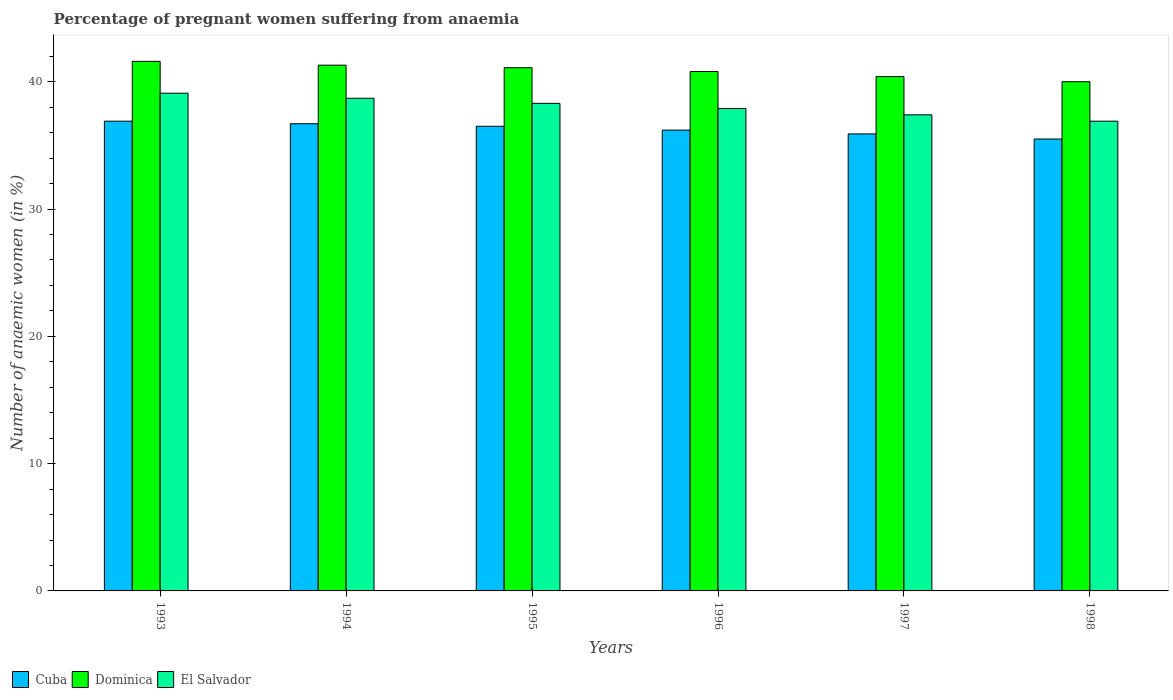Are the number of bars per tick equal to the number of legend labels?
Your answer should be very brief. Yes. How many bars are there on the 3rd tick from the left?
Provide a short and direct response. 3. How many bars are there on the 4th tick from the right?
Keep it short and to the point. 3. What is the label of the 1st group of bars from the left?
Give a very brief answer. 1993. In how many cases, is the number of bars for a given year not equal to the number of legend labels?
Make the answer very short. 0. What is the number of anaemic women in Dominica in 1994?
Give a very brief answer. 41.3. Across all years, what is the maximum number of anaemic women in Dominica?
Your answer should be very brief. 41.6. Across all years, what is the minimum number of anaemic women in Cuba?
Provide a succinct answer. 35.5. In which year was the number of anaemic women in El Salvador minimum?
Your answer should be compact. 1998. What is the total number of anaemic women in Dominica in the graph?
Offer a very short reply. 245.2. What is the difference between the number of anaemic women in Cuba in 1998 and the number of anaemic women in Dominica in 1994?
Your answer should be very brief. -5.8. What is the average number of anaemic women in Dominica per year?
Ensure brevity in your answer.  40.87. In the year 1998, what is the difference between the number of anaemic women in Dominica and number of anaemic women in El Salvador?
Your answer should be very brief. 3.1. What is the ratio of the number of anaemic women in El Salvador in 1993 to that in 1996?
Your answer should be compact. 1.03. What is the difference between the highest and the second highest number of anaemic women in Cuba?
Your answer should be compact. 0.2. What is the difference between the highest and the lowest number of anaemic women in El Salvador?
Provide a short and direct response. 2.2. What does the 2nd bar from the left in 1997 represents?
Offer a very short reply. Dominica. What does the 2nd bar from the right in 1995 represents?
Ensure brevity in your answer.  Dominica. Are the values on the major ticks of Y-axis written in scientific E-notation?
Offer a terse response. No. Does the graph contain any zero values?
Keep it short and to the point. No. Does the graph contain grids?
Keep it short and to the point. No. Where does the legend appear in the graph?
Offer a terse response. Bottom left. What is the title of the graph?
Make the answer very short. Percentage of pregnant women suffering from anaemia. What is the label or title of the Y-axis?
Give a very brief answer. Number of anaemic women (in %). What is the Number of anaemic women (in %) in Cuba in 1993?
Make the answer very short. 36.9. What is the Number of anaemic women (in %) of Dominica in 1993?
Offer a very short reply. 41.6. What is the Number of anaemic women (in %) in El Salvador in 1993?
Your response must be concise. 39.1. What is the Number of anaemic women (in %) of Cuba in 1994?
Your answer should be compact. 36.7. What is the Number of anaemic women (in %) of Dominica in 1994?
Your answer should be compact. 41.3. What is the Number of anaemic women (in %) in El Salvador in 1994?
Your answer should be very brief. 38.7. What is the Number of anaemic women (in %) in Cuba in 1995?
Your answer should be very brief. 36.5. What is the Number of anaemic women (in %) in Dominica in 1995?
Provide a succinct answer. 41.1. What is the Number of anaemic women (in %) of El Salvador in 1995?
Your answer should be very brief. 38.3. What is the Number of anaemic women (in %) in Cuba in 1996?
Your answer should be very brief. 36.2. What is the Number of anaemic women (in %) in Dominica in 1996?
Ensure brevity in your answer.  40.8. What is the Number of anaemic women (in %) of El Salvador in 1996?
Your answer should be very brief. 37.9. What is the Number of anaemic women (in %) of Cuba in 1997?
Ensure brevity in your answer.  35.9. What is the Number of anaemic women (in %) of Dominica in 1997?
Provide a succinct answer. 40.4. What is the Number of anaemic women (in %) of El Salvador in 1997?
Ensure brevity in your answer.  37.4. What is the Number of anaemic women (in %) of Cuba in 1998?
Your response must be concise. 35.5. What is the Number of anaemic women (in %) in Dominica in 1998?
Your answer should be compact. 40. What is the Number of anaemic women (in %) of El Salvador in 1998?
Give a very brief answer. 36.9. Across all years, what is the maximum Number of anaemic women (in %) in Cuba?
Make the answer very short. 36.9. Across all years, what is the maximum Number of anaemic women (in %) of Dominica?
Your answer should be very brief. 41.6. Across all years, what is the maximum Number of anaemic women (in %) in El Salvador?
Your answer should be compact. 39.1. Across all years, what is the minimum Number of anaemic women (in %) in Cuba?
Your answer should be compact. 35.5. Across all years, what is the minimum Number of anaemic women (in %) in El Salvador?
Your answer should be very brief. 36.9. What is the total Number of anaemic women (in %) in Cuba in the graph?
Give a very brief answer. 217.7. What is the total Number of anaemic women (in %) of Dominica in the graph?
Provide a succinct answer. 245.2. What is the total Number of anaemic women (in %) of El Salvador in the graph?
Ensure brevity in your answer.  228.3. What is the difference between the Number of anaemic women (in %) in Dominica in 1993 and that in 1994?
Provide a short and direct response. 0.3. What is the difference between the Number of anaemic women (in %) of Cuba in 1993 and that in 1996?
Your response must be concise. 0.7. What is the difference between the Number of anaemic women (in %) of Dominica in 1993 and that in 1996?
Offer a terse response. 0.8. What is the difference between the Number of anaemic women (in %) of El Salvador in 1993 and that in 1996?
Your answer should be very brief. 1.2. What is the difference between the Number of anaemic women (in %) of Cuba in 1993 and that in 1997?
Ensure brevity in your answer.  1. What is the difference between the Number of anaemic women (in %) in Dominica in 1993 and that in 1997?
Provide a succinct answer. 1.2. What is the difference between the Number of anaemic women (in %) of El Salvador in 1993 and that in 1997?
Provide a short and direct response. 1.7. What is the difference between the Number of anaemic women (in %) of Cuba in 1993 and that in 1998?
Offer a very short reply. 1.4. What is the difference between the Number of anaemic women (in %) in Cuba in 1994 and that in 1995?
Provide a short and direct response. 0.2. What is the difference between the Number of anaemic women (in %) of Dominica in 1994 and that in 1995?
Offer a terse response. 0.2. What is the difference between the Number of anaemic women (in %) in El Salvador in 1994 and that in 1996?
Your answer should be very brief. 0.8. What is the difference between the Number of anaemic women (in %) in Cuba in 1994 and that in 1997?
Your response must be concise. 0.8. What is the difference between the Number of anaemic women (in %) in El Salvador in 1994 and that in 1997?
Your answer should be compact. 1.3. What is the difference between the Number of anaemic women (in %) of Cuba in 1994 and that in 1998?
Your answer should be compact. 1.2. What is the difference between the Number of anaemic women (in %) in Dominica in 1994 and that in 1998?
Make the answer very short. 1.3. What is the difference between the Number of anaemic women (in %) of Cuba in 1995 and that in 1996?
Give a very brief answer. 0.3. What is the difference between the Number of anaemic women (in %) in Dominica in 1995 and that in 1996?
Your answer should be very brief. 0.3. What is the difference between the Number of anaemic women (in %) of El Salvador in 1995 and that in 1996?
Offer a very short reply. 0.4. What is the difference between the Number of anaemic women (in %) in Cuba in 1995 and that in 1998?
Offer a very short reply. 1. What is the difference between the Number of anaemic women (in %) of Dominica in 1995 and that in 1998?
Ensure brevity in your answer.  1.1. What is the difference between the Number of anaemic women (in %) of Dominica in 1996 and that in 1997?
Your response must be concise. 0.4. What is the difference between the Number of anaemic women (in %) in El Salvador in 1996 and that in 1997?
Keep it short and to the point. 0.5. What is the difference between the Number of anaemic women (in %) of Cuba in 1996 and that in 1998?
Ensure brevity in your answer.  0.7. What is the difference between the Number of anaemic women (in %) of El Salvador in 1996 and that in 1998?
Offer a very short reply. 1. What is the difference between the Number of anaemic women (in %) in Cuba in 1997 and that in 1998?
Ensure brevity in your answer.  0.4. What is the difference between the Number of anaemic women (in %) of Dominica in 1997 and that in 1998?
Provide a short and direct response. 0.4. What is the difference between the Number of anaemic women (in %) of El Salvador in 1997 and that in 1998?
Your response must be concise. 0.5. What is the difference between the Number of anaemic women (in %) in Dominica in 1993 and the Number of anaemic women (in %) in El Salvador in 1994?
Provide a succinct answer. 2.9. What is the difference between the Number of anaemic women (in %) in Dominica in 1993 and the Number of anaemic women (in %) in El Salvador in 1995?
Your answer should be compact. 3.3. What is the difference between the Number of anaemic women (in %) in Dominica in 1993 and the Number of anaemic women (in %) in El Salvador in 1996?
Make the answer very short. 3.7. What is the difference between the Number of anaemic women (in %) of Cuba in 1993 and the Number of anaemic women (in %) of El Salvador in 1997?
Make the answer very short. -0.5. What is the difference between the Number of anaemic women (in %) in Dominica in 1993 and the Number of anaemic women (in %) in El Salvador in 1997?
Keep it short and to the point. 4.2. What is the difference between the Number of anaemic women (in %) of Cuba in 1994 and the Number of anaemic women (in %) of Dominica in 1995?
Make the answer very short. -4.4. What is the difference between the Number of anaemic women (in %) of Cuba in 1994 and the Number of anaemic women (in %) of El Salvador in 1996?
Your response must be concise. -1.2. What is the difference between the Number of anaemic women (in %) of Dominica in 1994 and the Number of anaemic women (in %) of El Salvador in 1996?
Offer a terse response. 3.4. What is the difference between the Number of anaemic women (in %) of Cuba in 1994 and the Number of anaemic women (in %) of El Salvador in 1997?
Offer a terse response. -0.7. What is the difference between the Number of anaemic women (in %) of Dominica in 1994 and the Number of anaemic women (in %) of El Salvador in 1997?
Your answer should be compact. 3.9. What is the difference between the Number of anaemic women (in %) in Cuba in 1994 and the Number of anaemic women (in %) in Dominica in 1998?
Make the answer very short. -3.3. What is the difference between the Number of anaemic women (in %) of Cuba in 1995 and the Number of anaemic women (in %) of Dominica in 1997?
Keep it short and to the point. -3.9. What is the difference between the Number of anaemic women (in %) in Cuba in 1995 and the Number of anaemic women (in %) in El Salvador in 1997?
Provide a succinct answer. -0.9. What is the difference between the Number of anaemic women (in %) of Dominica in 1995 and the Number of anaemic women (in %) of El Salvador in 1997?
Provide a short and direct response. 3.7. What is the difference between the Number of anaemic women (in %) in Dominica in 1995 and the Number of anaemic women (in %) in El Salvador in 1998?
Give a very brief answer. 4.2. What is the difference between the Number of anaemic women (in %) in Cuba in 1996 and the Number of anaemic women (in %) in El Salvador in 1997?
Give a very brief answer. -1.2. What is the difference between the Number of anaemic women (in %) in Dominica in 1996 and the Number of anaemic women (in %) in El Salvador in 1997?
Ensure brevity in your answer.  3.4. What is the difference between the Number of anaemic women (in %) of Cuba in 1997 and the Number of anaemic women (in %) of El Salvador in 1998?
Keep it short and to the point. -1. What is the difference between the Number of anaemic women (in %) in Dominica in 1997 and the Number of anaemic women (in %) in El Salvador in 1998?
Keep it short and to the point. 3.5. What is the average Number of anaemic women (in %) of Cuba per year?
Provide a succinct answer. 36.28. What is the average Number of anaemic women (in %) in Dominica per year?
Your answer should be compact. 40.87. What is the average Number of anaemic women (in %) of El Salvador per year?
Make the answer very short. 38.05. In the year 1993, what is the difference between the Number of anaemic women (in %) in Cuba and Number of anaemic women (in %) in Dominica?
Provide a succinct answer. -4.7. In the year 1993, what is the difference between the Number of anaemic women (in %) in Cuba and Number of anaemic women (in %) in El Salvador?
Offer a very short reply. -2.2. In the year 1993, what is the difference between the Number of anaemic women (in %) in Dominica and Number of anaemic women (in %) in El Salvador?
Provide a short and direct response. 2.5. In the year 1994, what is the difference between the Number of anaemic women (in %) in Cuba and Number of anaemic women (in %) in Dominica?
Ensure brevity in your answer.  -4.6. In the year 1994, what is the difference between the Number of anaemic women (in %) in Dominica and Number of anaemic women (in %) in El Salvador?
Provide a short and direct response. 2.6. In the year 1997, what is the difference between the Number of anaemic women (in %) in Cuba and Number of anaemic women (in %) in El Salvador?
Your answer should be compact. -1.5. In the year 1997, what is the difference between the Number of anaemic women (in %) of Dominica and Number of anaemic women (in %) of El Salvador?
Your answer should be very brief. 3. In the year 1998, what is the difference between the Number of anaemic women (in %) of Cuba and Number of anaemic women (in %) of Dominica?
Your response must be concise. -4.5. In the year 1998, what is the difference between the Number of anaemic women (in %) in Cuba and Number of anaemic women (in %) in El Salvador?
Offer a terse response. -1.4. In the year 1998, what is the difference between the Number of anaemic women (in %) of Dominica and Number of anaemic women (in %) of El Salvador?
Provide a short and direct response. 3.1. What is the ratio of the Number of anaemic women (in %) of Cuba in 1993 to that in 1994?
Provide a short and direct response. 1.01. What is the ratio of the Number of anaemic women (in %) in Dominica in 1993 to that in 1994?
Ensure brevity in your answer.  1.01. What is the ratio of the Number of anaemic women (in %) of El Salvador in 1993 to that in 1994?
Make the answer very short. 1.01. What is the ratio of the Number of anaemic women (in %) of Cuba in 1993 to that in 1995?
Provide a succinct answer. 1.01. What is the ratio of the Number of anaemic women (in %) of Dominica in 1993 to that in 1995?
Make the answer very short. 1.01. What is the ratio of the Number of anaemic women (in %) in El Salvador in 1993 to that in 1995?
Give a very brief answer. 1.02. What is the ratio of the Number of anaemic women (in %) of Cuba in 1993 to that in 1996?
Your answer should be very brief. 1.02. What is the ratio of the Number of anaemic women (in %) of Dominica in 1993 to that in 1996?
Keep it short and to the point. 1.02. What is the ratio of the Number of anaemic women (in %) in El Salvador in 1993 to that in 1996?
Your answer should be very brief. 1.03. What is the ratio of the Number of anaemic women (in %) of Cuba in 1993 to that in 1997?
Ensure brevity in your answer.  1.03. What is the ratio of the Number of anaemic women (in %) of Dominica in 1993 to that in 1997?
Provide a succinct answer. 1.03. What is the ratio of the Number of anaemic women (in %) of El Salvador in 1993 to that in 1997?
Ensure brevity in your answer.  1.05. What is the ratio of the Number of anaemic women (in %) in Cuba in 1993 to that in 1998?
Offer a terse response. 1.04. What is the ratio of the Number of anaemic women (in %) of El Salvador in 1993 to that in 1998?
Provide a short and direct response. 1.06. What is the ratio of the Number of anaemic women (in %) in Cuba in 1994 to that in 1995?
Make the answer very short. 1.01. What is the ratio of the Number of anaemic women (in %) of Dominica in 1994 to that in 1995?
Offer a very short reply. 1. What is the ratio of the Number of anaemic women (in %) of El Salvador in 1994 to that in 1995?
Make the answer very short. 1.01. What is the ratio of the Number of anaemic women (in %) in Cuba in 1994 to that in 1996?
Your response must be concise. 1.01. What is the ratio of the Number of anaemic women (in %) of Dominica in 1994 to that in 1996?
Keep it short and to the point. 1.01. What is the ratio of the Number of anaemic women (in %) of El Salvador in 1994 to that in 1996?
Ensure brevity in your answer.  1.02. What is the ratio of the Number of anaemic women (in %) of Cuba in 1994 to that in 1997?
Your answer should be very brief. 1.02. What is the ratio of the Number of anaemic women (in %) of Dominica in 1994 to that in 1997?
Provide a short and direct response. 1.02. What is the ratio of the Number of anaemic women (in %) in El Salvador in 1994 to that in 1997?
Your response must be concise. 1.03. What is the ratio of the Number of anaemic women (in %) in Cuba in 1994 to that in 1998?
Your answer should be very brief. 1.03. What is the ratio of the Number of anaemic women (in %) in Dominica in 1994 to that in 1998?
Your answer should be compact. 1.03. What is the ratio of the Number of anaemic women (in %) of El Salvador in 1994 to that in 1998?
Your response must be concise. 1.05. What is the ratio of the Number of anaemic women (in %) in Cuba in 1995 to that in 1996?
Keep it short and to the point. 1.01. What is the ratio of the Number of anaemic women (in %) of Dominica in 1995 to that in 1996?
Your answer should be compact. 1.01. What is the ratio of the Number of anaemic women (in %) in El Salvador in 1995 to that in 1996?
Make the answer very short. 1.01. What is the ratio of the Number of anaemic women (in %) of Cuba in 1995 to that in 1997?
Your response must be concise. 1.02. What is the ratio of the Number of anaemic women (in %) in Dominica in 1995 to that in 1997?
Your answer should be very brief. 1.02. What is the ratio of the Number of anaemic women (in %) in El Salvador in 1995 to that in 1997?
Give a very brief answer. 1.02. What is the ratio of the Number of anaemic women (in %) of Cuba in 1995 to that in 1998?
Provide a short and direct response. 1.03. What is the ratio of the Number of anaemic women (in %) of Dominica in 1995 to that in 1998?
Provide a succinct answer. 1.03. What is the ratio of the Number of anaemic women (in %) in El Salvador in 1995 to that in 1998?
Keep it short and to the point. 1.04. What is the ratio of the Number of anaemic women (in %) in Cuba in 1996 to that in 1997?
Give a very brief answer. 1.01. What is the ratio of the Number of anaemic women (in %) in Dominica in 1996 to that in 1997?
Offer a terse response. 1.01. What is the ratio of the Number of anaemic women (in %) of El Salvador in 1996 to that in 1997?
Provide a succinct answer. 1.01. What is the ratio of the Number of anaemic women (in %) in Cuba in 1996 to that in 1998?
Offer a terse response. 1.02. What is the ratio of the Number of anaemic women (in %) of Dominica in 1996 to that in 1998?
Offer a very short reply. 1.02. What is the ratio of the Number of anaemic women (in %) of El Salvador in 1996 to that in 1998?
Offer a terse response. 1.03. What is the ratio of the Number of anaemic women (in %) in Cuba in 1997 to that in 1998?
Your answer should be compact. 1.01. What is the ratio of the Number of anaemic women (in %) in El Salvador in 1997 to that in 1998?
Your answer should be very brief. 1.01. What is the difference between the highest and the second highest Number of anaemic women (in %) of Cuba?
Your answer should be compact. 0.2. What is the difference between the highest and the second highest Number of anaemic women (in %) of Dominica?
Keep it short and to the point. 0.3. What is the difference between the highest and the second highest Number of anaemic women (in %) of El Salvador?
Provide a succinct answer. 0.4. What is the difference between the highest and the lowest Number of anaemic women (in %) in Cuba?
Your response must be concise. 1.4. What is the difference between the highest and the lowest Number of anaemic women (in %) of Dominica?
Provide a short and direct response. 1.6. 